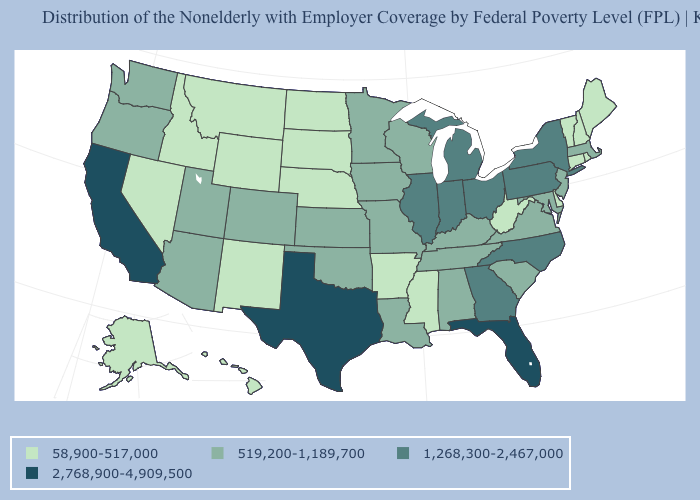What is the value of Vermont?
Keep it brief. 58,900-517,000. Does Tennessee have a higher value than Maine?
Concise answer only. Yes. What is the value of Montana?
Keep it brief. 58,900-517,000. What is the value of Utah?
Quick response, please. 519,200-1,189,700. Among the states that border Massachusetts , which have the highest value?
Concise answer only. New York. Does Oregon have a lower value than Florida?
Concise answer only. Yes. What is the lowest value in the USA?
Answer briefly. 58,900-517,000. Name the states that have a value in the range 519,200-1,189,700?
Concise answer only. Alabama, Arizona, Colorado, Iowa, Kansas, Kentucky, Louisiana, Maryland, Massachusetts, Minnesota, Missouri, New Jersey, Oklahoma, Oregon, South Carolina, Tennessee, Utah, Virginia, Washington, Wisconsin. What is the value of Louisiana?
Give a very brief answer. 519,200-1,189,700. Does North Carolina have a lower value than California?
Give a very brief answer. Yes. Does Maryland have the lowest value in the USA?
Write a very short answer. No. What is the highest value in states that border Arkansas?
Short answer required. 2,768,900-4,909,500. What is the lowest value in the West?
Answer briefly. 58,900-517,000. Among the states that border South Carolina , which have the lowest value?
Keep it brief. Georgia, North Carolina. Does Colorado have the same value as Missouri?
Answer briefly. Yes. 